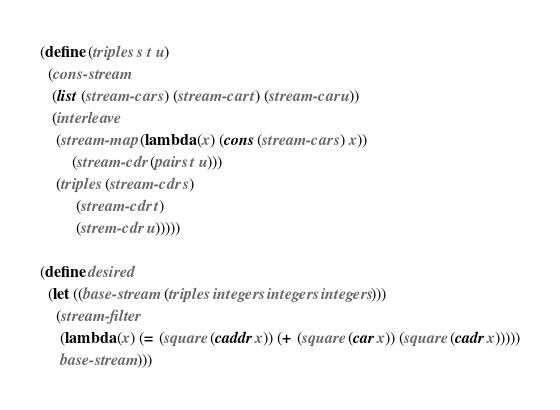Convert code to text. <code><loc_0><loc_0><loc_500><loc_500><_Scheme_>(define (triples s t u)
  (cons-stream
   (list (stream-car s) (stream-car t) (stream-car u))
   (interleave
    (stream-map (lambda (x) (cons (stream-car s) x))
		(stream-cdr (pairs t u)))
    (triples (stream-cdr s)
	     (stream-cdr t)
	     (strem-cdr u)))))

(define desired
  (let ((base-stream (triples integers integers integers)))
    (stream-filter
     (lambda (x) (= (square (caddr x)) (+ (square (car x)) (square (cadr x)))))
     base-stream)))
</code> 